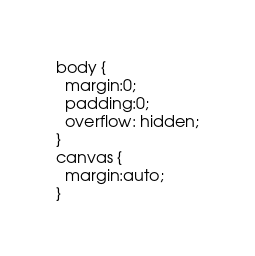Convert code to text. <code><loc_0><loc_0><loc_500><loc_500><_CSS_>body {
  margin:0;
  padding:0;
  overflow: hidden;
}
canvas {
  margin:auto;
}</code> 